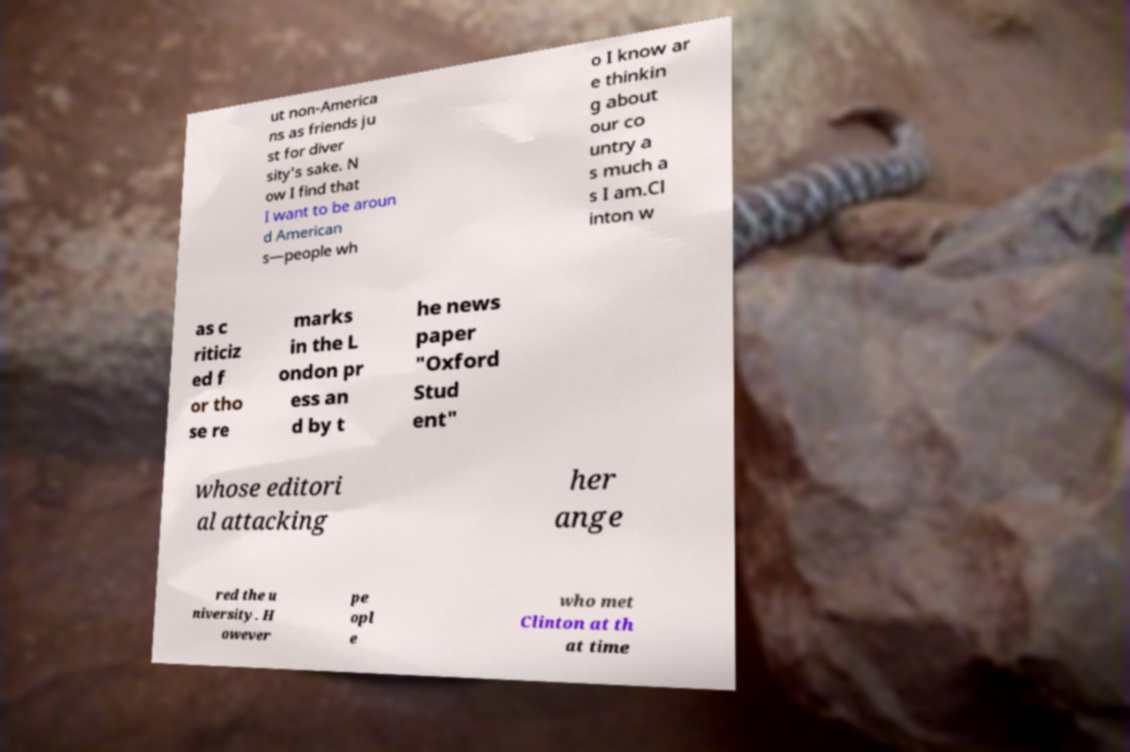I need the written content from this picture converted into text. Can you do that? ut non-America ns as friends ju st for diver sity's sake. N ow I find that I want to be aroun d American s—people wh o I know ar e thinkin g about our co untry a s much a s I am.Cl inton w as c riticiz ed f or tho se re marks in the L ondon pr ess an d by t he news paper "Oxford Stud ent" whose editori al attacking her ange red the u niversity. H owever pe opl e who met Clinton at th at time 